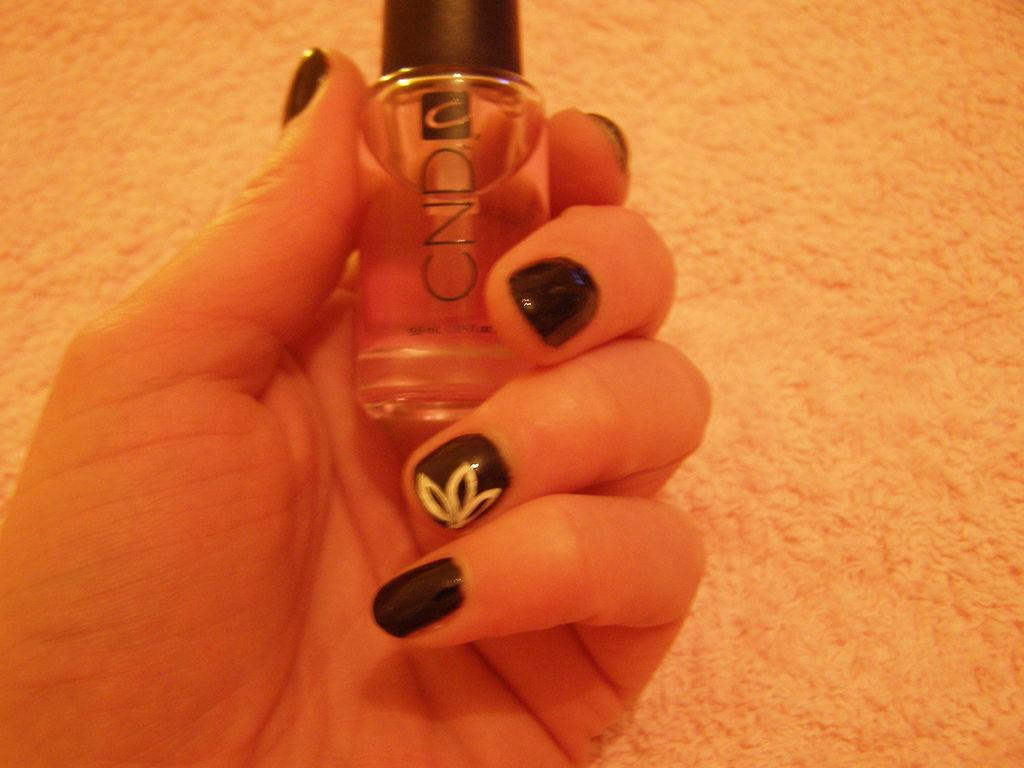<image>
Provide a brief description of the given image. A women with black painted nails holding a bottle of CND nail polish. 